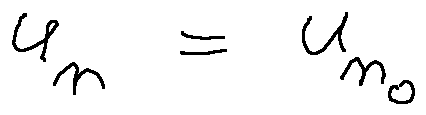<formula> <loc_0><loc_0><loc_500><loc_500>u _ { n } = u _ { n _ { 0 } }</formula> 